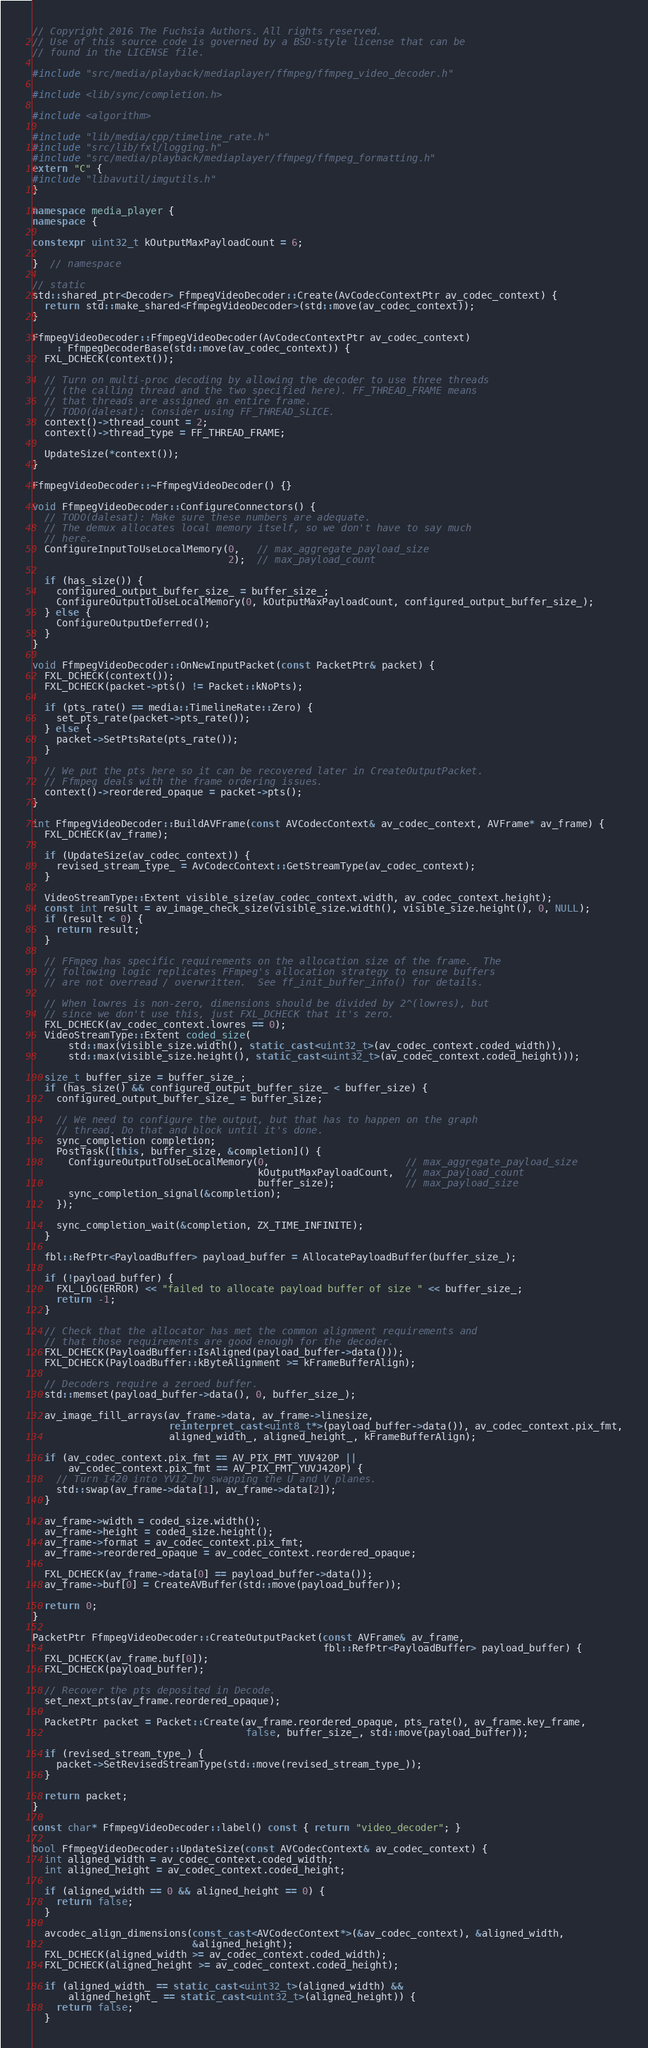<code> <loc_0><loc_0><loc_500><loc_500><_C++_>// Copyright 2016 The Fuchsia Authors. All rights reserved.
// Use of this source code is governed by a BSD-style license that can be
// found in the LICENSE file.

#include "src/media/playback/mediaplayer/ffmpeg/ffmpeg_video_decoder.h"

#include <lib/sync/completion.h>

#include <algorithm>

#include "lib/media/cpp/timeline_rate.h"
#include "src/lib/fxl/logging.h"
#include "src/media/playback/mediaplayer/ffmpeg/ffmpeg_formatting.h"
extern "C" {
#include "libavutil/imgutils.h"
}

namespace media_player {
namespace {

constexpr uint32_t kOutputMaxPayloadCount = 6;

}  // namespace

// static
std::shared_ptr<Decoder> FfmpegVideoDecoder::Create(AvCodecContextPtr av_codec_context) {
  return std::make_shared<FfmpegVideoDecoder>(std::move(av_codec_context));
}

FfmpegVideoDecoder::FfmpegVideoDecoder(AvCodecContextPtr av_codec_context)
    : FfmpegDecoderBase(std::move(av_codec_context)) {
  FXL_DCHECK(context());

  // Turn on multi-proc decoding by allowing the decoder to use three threads
  // (the calling thread and the two specified here). FF_THREAD_FRAME means
  // that threads are assigned an entire frame.
  // TODO(dalesat): Consider using FF_THREAD_SLICE.
  context()->thread_count = 2;
  context()->thread_type = FF_THREAD_FRAME;

  UpdateSize(*context());
}

FfmpegVideoDecoder::~FfmpegVideoDecoder() {}

void FfmpegVideoDecoder::ConfigureConnectors() {
  // TODO(dalesat): Make sure these numbers are adequate.
  // The demux allocates local memory itself, so we don't have to say much
  // here.
  ConfigureInputToUseLocalMemory(0,   // max_aggregate_payload_size
                                 2);  // max_payload_count

  if (has_size()) {
    configured_output_buffer_size_ = buffer_size_;
    ConfigureOutputToUseLocalMemory(0, kOutputMaxPayloadCount, configured_output_buffer_size_);
  } else {
    ConfigureOutputDeferred();
  }
}

void FfmpegVideoDecoder::OnNewInputPacket(const PacketPtr& packet) {
  FXL_DCHECK(context());
  FXL_DCHECK(packet->pts() != Packet::kNoPts);

  if (pts_rate() == media::TimelineRate::Zero) {
    set_pts_rate(packet->pts_rate());
  } else {
    packet->SetPtsRate(pts_rate());
  }

  // We put the pts here so it can be recovered later in CreateOutputPacket.
  // Ffmpeg deals with the frame ordering issues.
  context()->reordered_opaque = packet->pts();
}

int FfmpegVideoDecoder::BuildAVFrame(const AVCodecContext& av_codec_context, AVFrame* av_frame) {
  FXL_DCHECK(av_frame);

  if (UpdateSize(av_codec_context)) {
    revised_stream_type_ = AvCodecContext::GetStreamType(av_codec_context);
  }

  VideoStreamType::Extent visible_size(av_codec_context.width, av_codec_context.height);
  const int result = av_image_check_size(visible_size.width(), visible_size.height(), 0, NULL);
  if (result < 0) {
    return result;
  }

  // FFmpeg has specific requirements on the allocation size of the frame.  The
  // following logic replicates FFmpeg's allocation strategy to ensure buffers
  // are not overread / overwritten.  See ff_init_buffer_info() for details.

  // When lowres is non-zero, dimensions should be divided by 2^(lowres), but
  // since we don't use this, just FXL_DCHECK that it's zero.
  FXL_DCHECK(av_codec_context.lowres == 0);
  VideoStreamType::Extent coded_size(
      std::max(visible_size.width(), static_cast<uint32_t>(av_codec_context.coded_width)),
      std::max(visible_size.height(), static_cast<uint32_t>(av_codec_context.coded_height)));

  size_t buffer_size = buffer_size_;
  if (has_size() && configured_output_buffer_size_ < buffer_size) {
    configured_output_buffer_size_ = buffer_size;

    // We need to configure the output, but that has to happen on the graph
    // thread. Do that and block until it's done.
    sync_completion completion;
    PostTask([this, buffer_size, &completion]() {
      ConfigureOutputToUseLocalMemory(0,                       // max_aggregate_payload_size
                                      kOutputMaxPayloadCount,  // max_payload_count
                                      buffer_size);            // max_payload_size
      sync_completion_signal(&completion);
    });

    sync_completion_wait(&completion, ZX_TIME_INFINITE);
  }

  fbl::RefPtr<PayloadBuffer> payload_buffer = AllocatePayloadBuffer(buffer_size_);

  if (!payload_buffer) {
    FXL_LOG(ERROR) << "failed to allocate payload buffer of size " << buffer_size_;
    return -1;
  }

  // Check that the allocator has met the common alignment requirements and
  // that those requirements are good enough for the decoder.
  FXL_DCHECK(PayloadBuffer::IsAligned(payload_buffer->data()));
  FXL_DCHECK(PayloadBuffer::kByteAlignment >= kFrameBufferAlign);

  // Decoders require a zeroed buffer.
  std::memset(payload_buffer->data(), 0, buffer_size_);

  av_image_fill_arrays(av_frame->data, av_frame->linesize,
                       reinterpret_cast<uint8_t*>(payload_buffer->data()), av_codec_context.pix_fmt,
                       aligned_width_, aligned_height_, kFrameBufferAlign);

  if (av_codec_context.pix_fmt == AV_PIX_FMT_YUV420P ||
      av_codec_context.pix_fmt == AV_PIX_FMT_YUVJ420P) {
    // Turn I420 into YV12 by swapping the U and V planes.
    std::swap(av_frame->data[1], av_frame->data[2]);
  }

  av_frame->width = coded_size.width();
  av_frame->height = coded_size.height();
  av_frame->format = av_codec_context.pix_fmt;
  av_frame->reordered_opaque = av_codec_context.reordered_opaque;

  FXL_DCHECK(av_frame->data[0] == payload_buffer->data());
  av_frame->buf[0] = CreateAVBuffer(std::move(payload_buffer));

  return 0;
}

PacketPtr FfmpegVideoDecoder::CreateOutputPacket(const AVFrame& av_frame,
                                                 fbl::RefPtr<PayloadBuffer> payload_buffer) {
  FXL_DCHECK(av_frame.buf[0]);
  FXL_DCHECK(payload_buffer);

  // Recover the pts deposited in Decode.
  set_next_pts(av_frame.reordered_opaque);

  PacketPtr packet = Packet::Create(av_frame.reordered_opaque, pts_rate(), av_frame.key_frame,
                                    false, buffer_size_, std::move(payload_buffer));

  if (revised_stream_type_) {
    packet->SetRevisedStreamType(std::move(revised_stream_type_));
  }

  return packet;
}

const char* FfmpegVideoDecoder::label() const { return "video_decoder"; }

bool FfmpegVideoDecoder::UpdateSize(const AVCodecContext& av_codec_context) {
  int aligned_width = av_codec_context.coded_width;
  int aligned_height = av_codec_context.coded_height;

  if (aligned_width == 0 && aligned_height == 0) {
    return false;
  }

  avcodec_align_dimensions(const_cast<AVCodecContext*>(&av_codec_context), &aligned_width,
                           &aligned_height);
  FXL_DCHECK(aligned_width >= av_codec_context.coded_width);
  FXL_DCHECK(aligned_height >= av_codec_context.coded_height);

  if (aligned_width_ == static_cast<uint32_t>(aligned_width) &&
      aligned_height_ == static_cast<uint32_t>(aligned_height)) {
    return false;
  }
</code> 